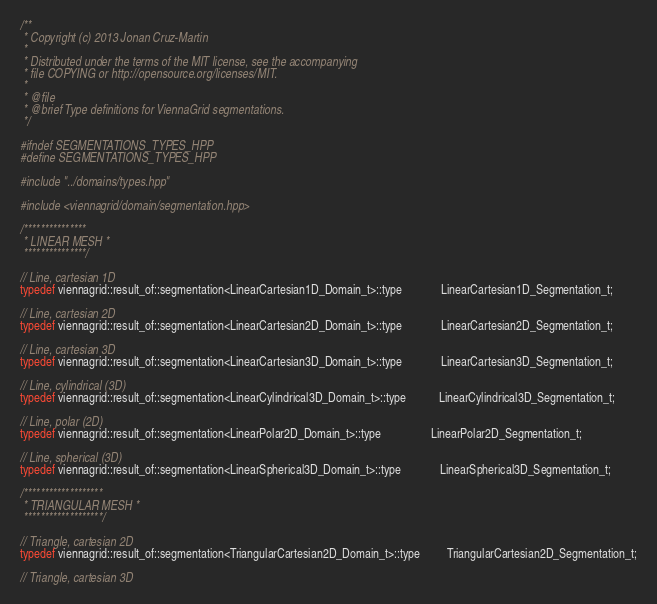<code> <loc_0><loc_0><loc_500><loc_500><_C++_>/**
 * Copyright (c) 2013 Jonan Cruz-Martin
 * 
 * Distributed under the terms of the MIT license, see the accompanying
 * file COPYING or http://opensource.org/licenses/MIT.
 * 
 * @file
 * @brief Type definitions for ViennaGrid segmentations.
 */

#ifndef SEGMENTATIONS_TYPES_HPP
#define SEGMENTATIONS_TYPES_HPP

#include "../domains/types.hpp"

#include <viennagrid/domain/segmentation.hpp>

/***************
 * LINEAR MESH *
 ***************/

// Line, cartesian 1D
typedef viennagrid::result_of::segmentation<LinearCartesian1D_Domain_t>::type             LinearCartesian1D_Segmentation_t;

// Line, cartesian 2D
typedef viennagrid::result_of::segmentation<LinearCartesian2D_Domain_t>::type             LinearCartesian2D_Segmentation_t;

// Line, cartesian 3D
typedef viennagrid::result_of::segmentation<LinearCartesian3D_Domain_t>::type             LinearCartesian3D_Segmentation_t;

// Line, cylindrical (3D)
typedef viennagrid::result_of::segmentation<LinearCylindrical3D_Domain_t>::type           LinearCylindrical3D_Segmentation_t;

// Line, polar (2D)
typedef viennagrid::result_of::segmentation<LinearPolar2D_Domain_t>::type                 LinearPolar2D_Segmentation_t;

// Line, spherical (3D)
typedef viennagrid::result_of::segmentation<LinearSpherical3D_Domain_t>::type             LinearSpherical3D_Segmentation_t;

/*******************
 * TRIANGULAR MESH *
 *******************/

// Triangle, cartesian 2D
typedef viennagrid::result_of::segmentation<TriangularCartesian2D_Domain_t>::type         TriangularCartesian2D_Segmentation_t;

// Triangle, cartesian 3D</code> 